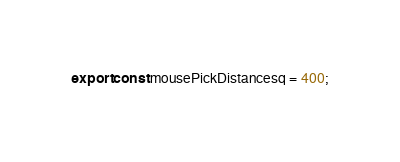<code> <loc_0><loc_0><loc_500><loc_500><_TypeScript_>export const mousePickDistancesq = 400;</code> 